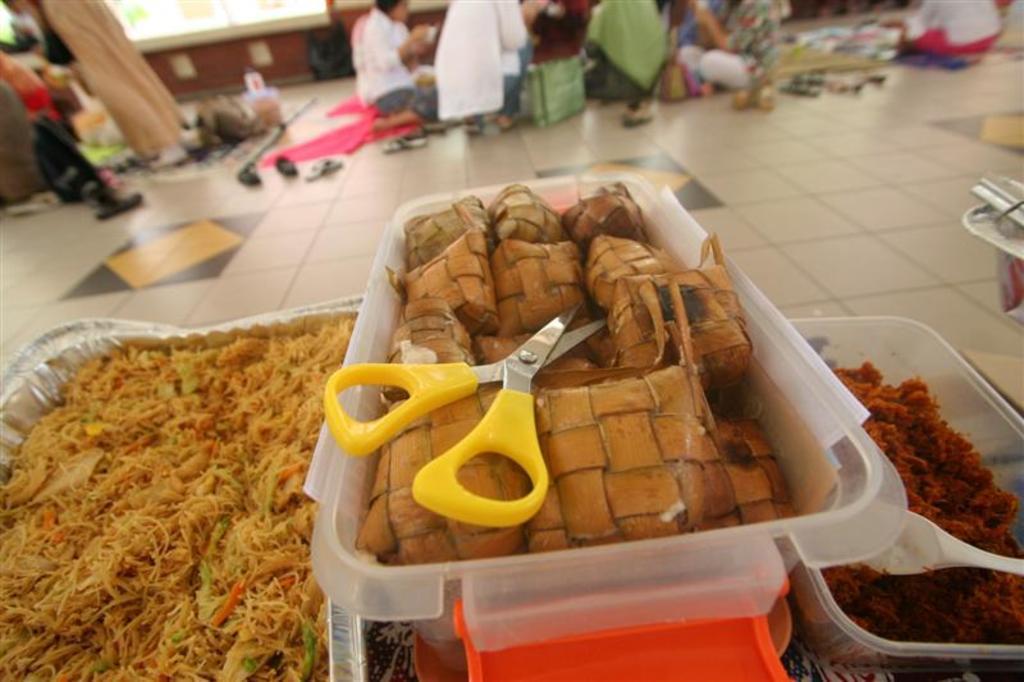Describe this image in one or two sentences. In this image, we can see food in the boxes and we can see scissors and a spoon. In the background, there are people and we can see some objects on the floor. 